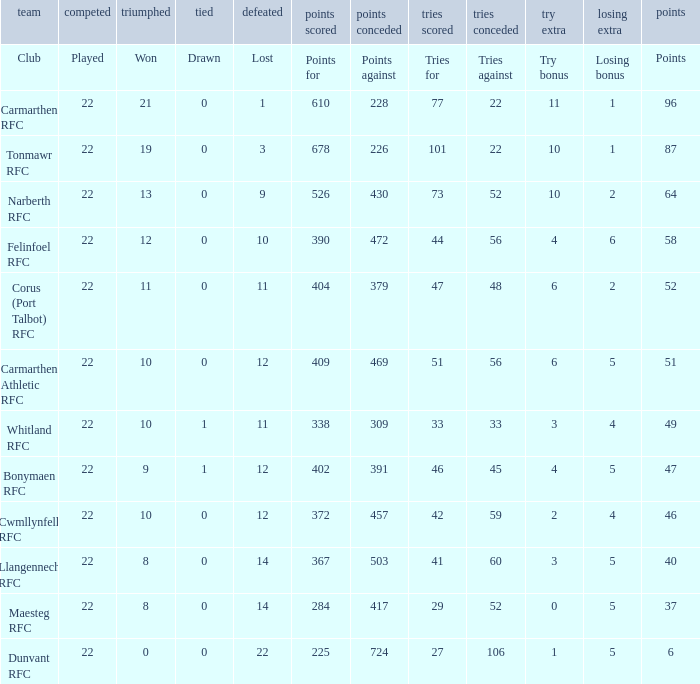Name the tries against for 87 points 22.0. 